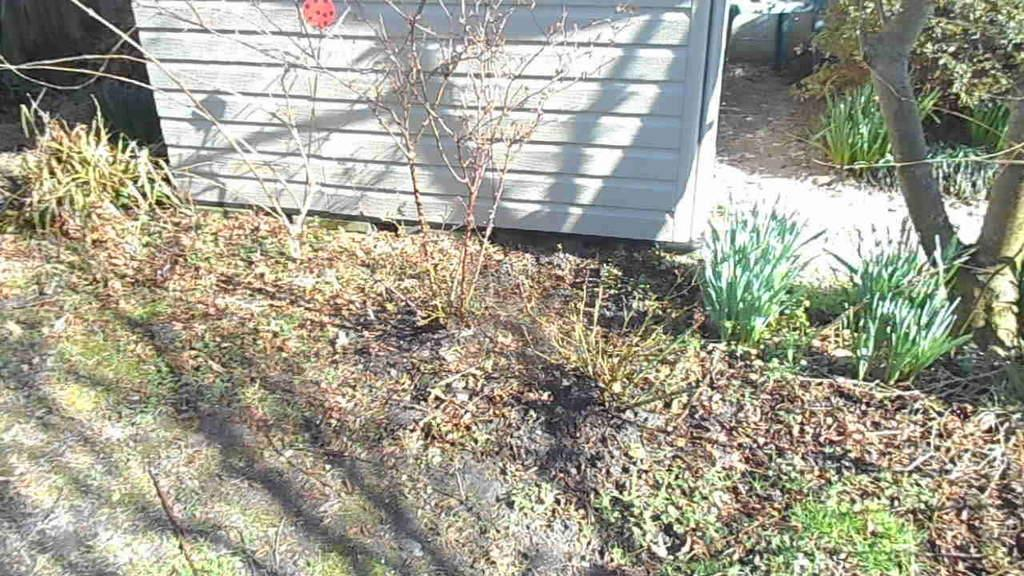What structure is located in the center of the image? There is a shed in the center of the image. What type of vegetation is on the right side of the image? There is a tree on the right side of the image. What type of natural environment is visible at the bottom of the image? Plants and grass are visible at the bottom of the image. What type of cork can be seen in the image? There is no cork present in the image. What does the tree say in the image? Trees do not have the ability to speak, so there is no voice in the image. 